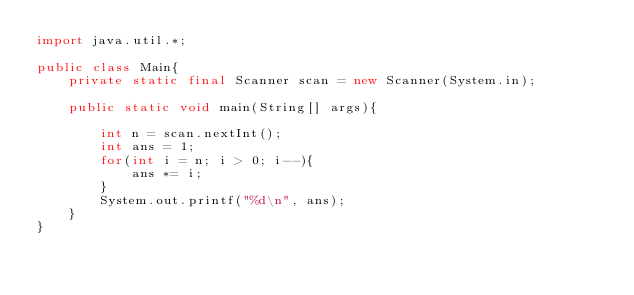Convert code to text. <code><loc_0><loc_0><loc_500><loc_500><_Java_>import java.util.*;

public class Main{
	private static final Scanner scan = new Scanner(System.in);

	public static void main(String[] args){
		
		int n = scan.nextInt();
		int ans = 1;
		for(int i = n; i > 0; i--){
			ans *= i;
		}
		System.out.printf("%d\n", ans);
	}
}</code> 